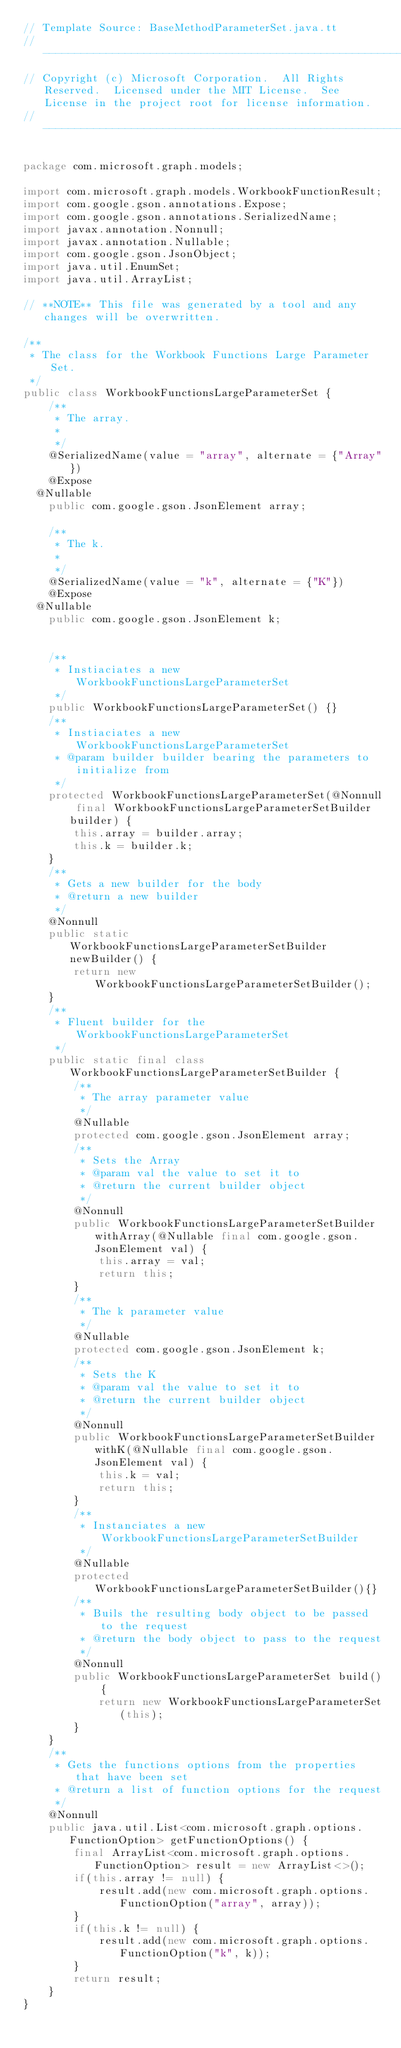<code> <loc_0><loc_0><loc_500><loc_500><_Java_>// Template Source: BaseMethodParameterSet.java.tt
// ------------------------------------------------------------------------------
// Copyright (c) Microsoft Corporation.  All Rights Reserved.  Licensed under the MIT License.  See License in the project root for license information.
// ------------------------------------------------------------------------------

package com.microsoft.graph.models;

import com.microsoft.graph.models.WorkbookFunctionResult;
import com.google.gson.annotations.Expose;
import com.google.gson.annotations.SerializedName;
import javax.annotation.Nonnull;
import javax.annotation.Nullable;
import com.google.gson.JsonObject;
import java.util.EnumSet;
import java.util.ArrayList;

// **NOTE** This file was generated by a tool and any changes will be overwritten.

/**
 * The class for the Workbook Functions Large Parameter Set.
 */
public class WorkbookFunctionsLargeParameterSet {
    /**
     * The array.
     * 
     */
    @SerializedName(value = "array", alternate = {"Array"})
    @Expose
	@Nullable
    public com.google.gson.JsonElement array;

    /**
     * The k.
     * 
     */
    @SerializedName(value = "k", alternate = {"K"})
    @Expose
	@Nullable
    public com.google.gson.JsonElement k;


    /**
     * Instiaciates a new WorkbookFunctionsLargeParameterSet
     */
    public WorkbookFunctionsLargeParameterSet() {}
    /**
     * Instiaciates a new WorkbookFunctionsLargeParameterSet
     * @param builder builder bearing the parameters to initialize from
     */
    protected WorkbookFunctionsLargeParameterSet(@Nonnull final WorkbookFunctionsLargeParameterSetBuilder builder) {
        this.array = builder.array;
        this.k = builder.k;
    }
    /**
     * Gets a new builder for the body
     * @return a new builder
     */
    @Nonnull
    public static WorkbookFunctionsLargeParameterSetBuilder newBuilder() {
        return new WorkbookFunctionsLargeParameterSetBuilder();
    }
    /**
     * Fluent builder for the WorkbookFunctionsLargeParameterSet
     */
    public static final class WorkbookFunctionsLargeParameterSetBuilder {
        /**
         * The array parameter value
         */
        @Nullable
        protected com.google.gson.JsonElement array;
        /**
         * Sets the Array
         * @param val the value to set it to
         * @return the current builder object
         */
        @Nonnull
        public WorkbookFunctionsLargeParameterSetBuilder withArray(@Nullable final com.google.gson.JsonElement val) {
            this.array = val;
            return this;
        }
        /**
         * The k parameter value
         */
        @Nullable
        protected com.google.gson.JsonElement k;
        /**
         * Sets the K
         * @param val the value to set it to
         * @return the current builder object
         */
        @Nonnull
        public WorkbookFunctionsLargeParameterSetBuilder withK(@Nullable final com.google.gson.JsonElement val) {
            this.k = val;
            return this;
        }
        /**
         * Instanciates a new WorkbookFunctionsLargeParameterSetBuilder
         */
        @Nullable
        protected WorkbookFunctionsLargeParameterSetBuilder(){}
        /**
         * Buils the resulting body object to be passed to the request
         * @return the body object to pass to the request
         */
        @Nonnull
        public WorkbookFunctionsLargeParameterSet build() {
            return new WorkbookFunctionsLargeParameterSet(this);
        }
    }
    /**
     * Gets the functions options from the properties that have been set
     * @return a list of function options for the request
     */
    @Nonnull
    public java.util.List<com.microsoft.graph.options.FunctionOption> getFunctionOptions() {
        final ArrayList<com.microsoft.graph.options.FunctionOption> result = new ArrayList<>();
        if(this.array != null) {
            result.add(new com.microsoft.graph.options.FunctionOption("array", array));
        }
        if(this.k != null) {
            result.add(new com.microsoft.graph.options.FunctionOption("k", k));
        }
        return result;
    }
}
</code> 